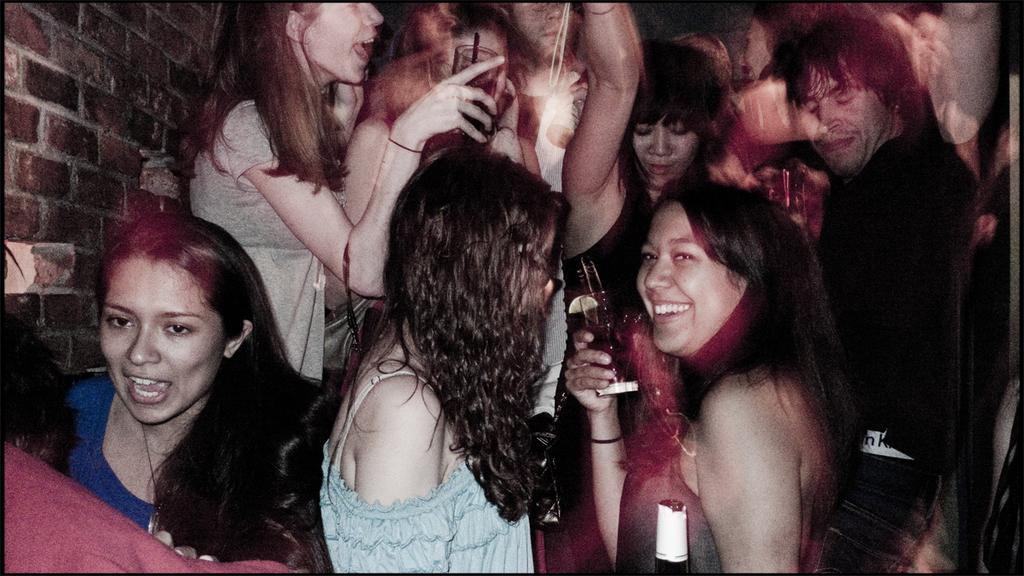How many people are in the image? There is a group of people in the image, but the exact number is not specified. What are some people holding in the image? Some people are holding glasses in the image. What can be seen in the background of the image? There is a wall visible in the image. How many cars are parked in front of the wall in the image? There are no cars visible in the image; only a group of people and a wall are present. What type of yoke is being used by the people in the image? There is no yoke present in the image; the people are holding glasses. 